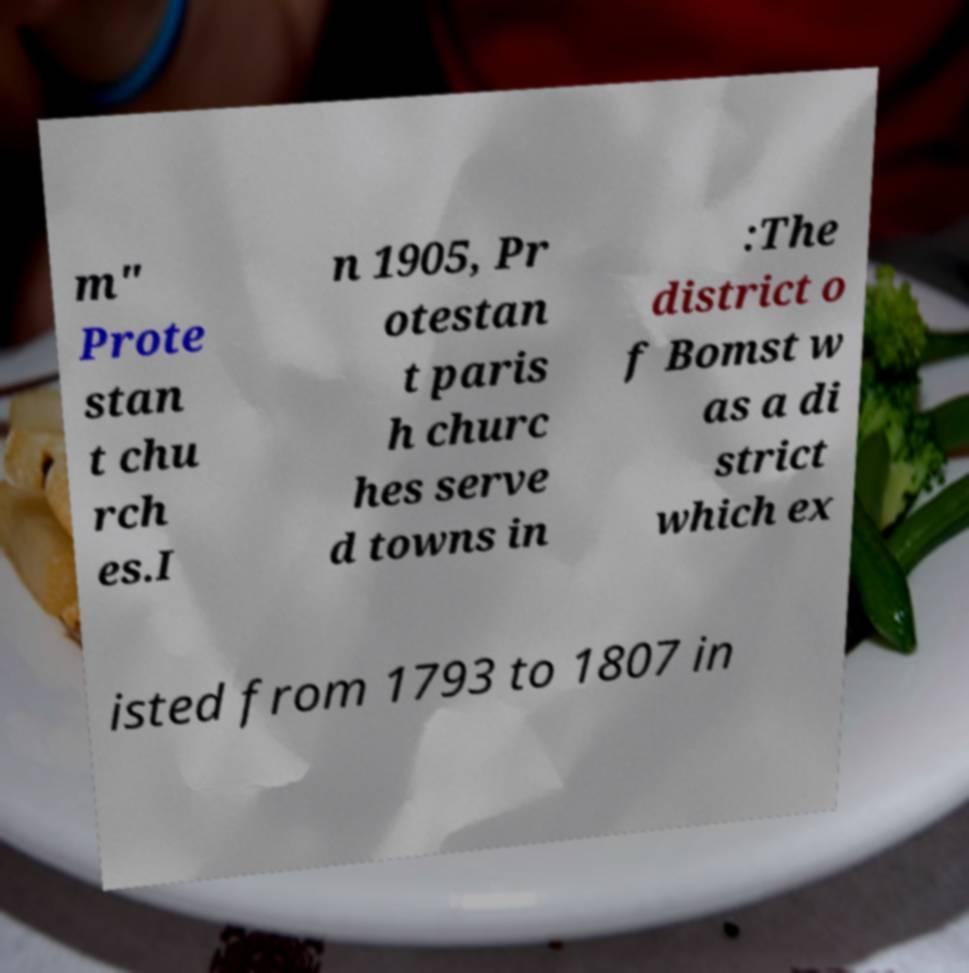Please read and relay the text visible in this image. What does it say? m" Prote stan t chu rch es.I n 1905, Pr otestan t paris h churc hes serve d towns in :The district o f Bomst w as a di strict which ex isted from 1793 to 1807 in 